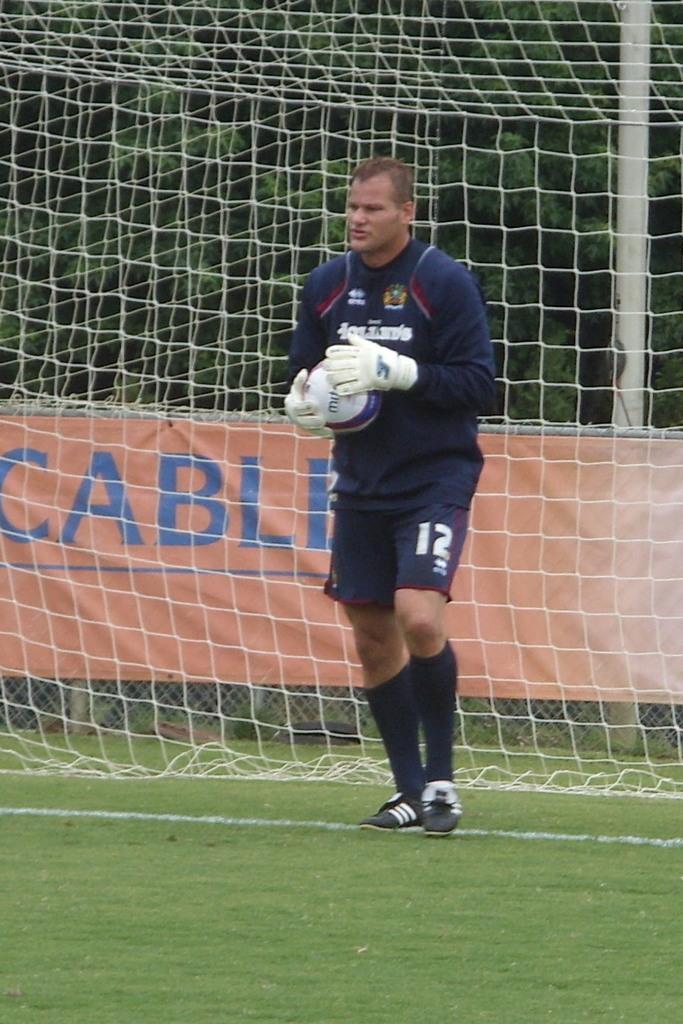How would you summarize this image in a sentence or two? There is a man holding a ball in his hand. In the background there is a net and there are trees. 